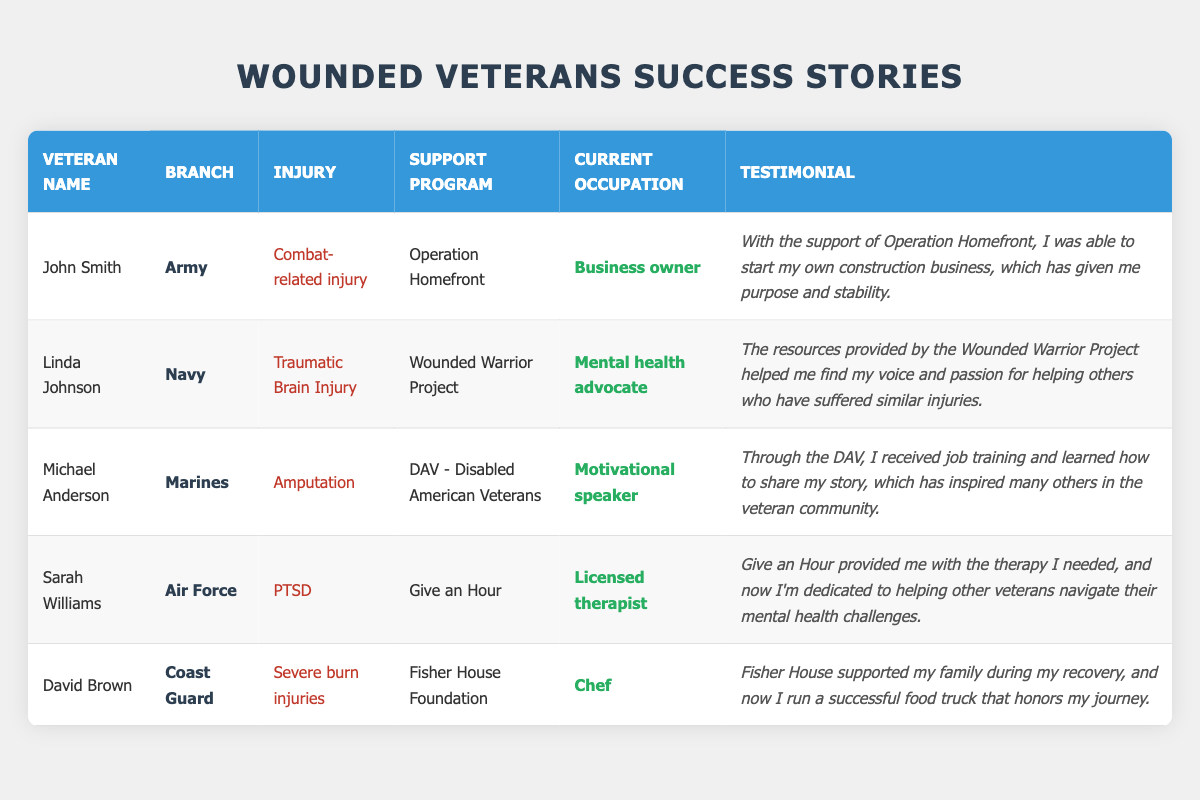What support program did John Smith use? According to the table, John Smith received support from "Operation Homefront." This information is directly found in the row corresponding to his name.
Answer: Operation Homefront Which branch had the veteran with a traumatic brain injury? The table shows that Linda Johnson, whose injury is a traumatic brain injury, served in the Navy. This is found in the row for Linda Johnson.
Answer: Navy How many veterans are currently employed as motivational speakers? By reviewing the table, only Michael Anderson is noted as a motivational speaker, indicating that there is one veteran with this occupation.
Answer: 1 What is Sarah Williams’ current occupation? The table lists Sarah Williams' current occupation as "Licensed therapist," which is found in her corresponding row.
Answer: Licensed therapist Which support program did David Brown participate in? The table specifies that David Brown participated in the "Fisher House Foundation" program, as indicated in his row of data.
Answer: Fisher House Foundation Is there a veteran from the Air Force who is a mental health advocate? The table indicates that Sarah Williams is from the Air Force, but her current occupation is a licensed therapist, not a mental health advocate. Linda Johnson is a mental health advocate but served in the Navy. Therefore, the answer is no.
Answer: No How many veterans mentioned received their support from the Wounded Warrior Project? In the table, only Linda Johnson is specified as receiving support from the Wounded Warrior Project. Thus, only one veteran was supported by this program.
Answer: 1 Which injury is associated with the veteran currently running a food truck? The table shows that David Brown, who runs a food truck, has severe burn injuries listed as his injury. This is verified in his corresponding data row.
Answer: Severe burn injuries What is the difference in the number of veterans supported by "Operation Homefront" and those supported by "DAV - Disabled American Veterans"? The table lists John Smith under "Operation Homefront" and Michael Anderson under "DAV." Thus, both programs each supported one veteran. The difference is 1 - 1 = 0. There is no difference in the number of veterans supported by these two programs.
Answer: 0 Did any veteran suffer from PTSD after serving in the military? Yes, the table indicates that Sarah Williams suffered from PTSD, which is noted in her data row. Therefore, the statement is true.
Answer: Yes How many veterans are there in total? The table comprises a total of five rows representing five veterans, which can be counted directly from the information provided.
Answer: 5 